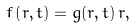<formula> <loc_0><loc_0><loc_500><loc_500>f \left ( r , t \right ) = g ( r , t ) \, r ,</formula> 